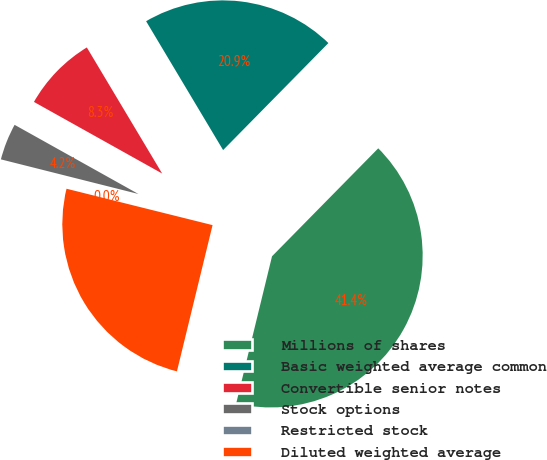<chart> <loc_0><loc_0><loc_500><loc_500><pie_chart><fcel>Millions of shares<fcel>Basic weighted average common<fcel>Convertible senior notes<fcel>Stock options<fcel>Restricted stock<fcel>Diluted weighted average<nl><fcel>41.43%<fcel>20.94%<fcel>8.32%<fcel>4.18%<fcel>0.04%<fcel>25.08%<nl></chart> 